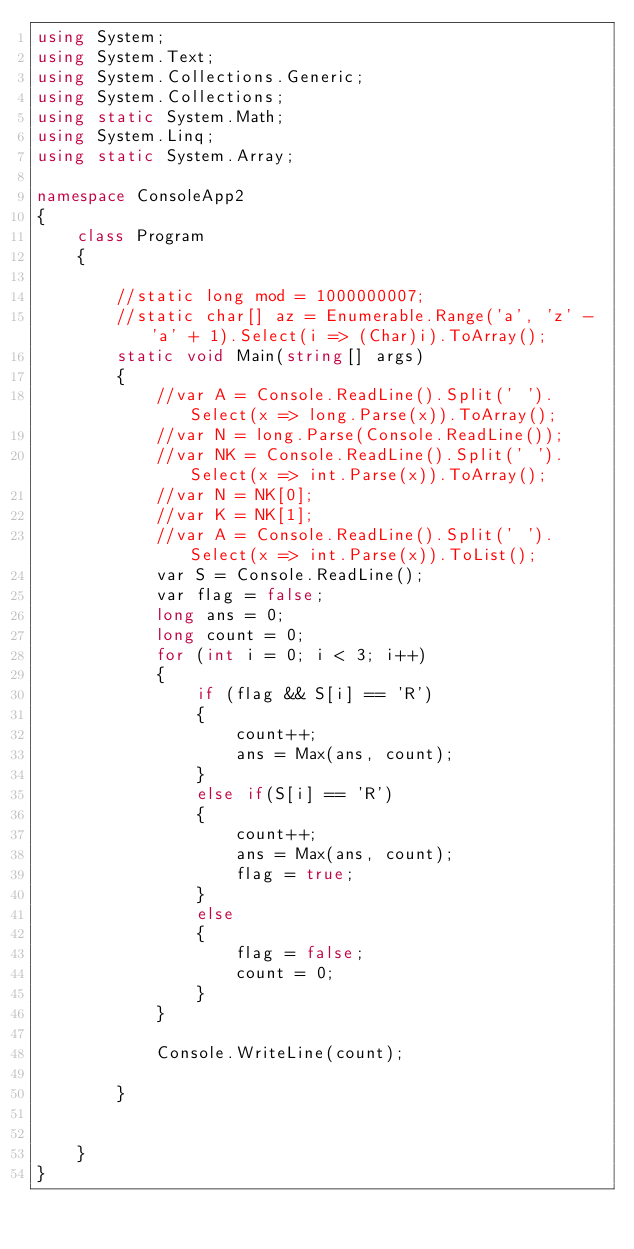Convert code to text. <code><loc_0><loc_0><loc_500><loc_500><_C#_>using System;
using System.Text;
using System.Collections.Generic;
using System.Collections;
using static System.Math;
using System.Linq;
using static System.Array;

namespace ConsoleApp2
{
    class Program
    {
        
        //static long mod = 1000000007;
        //static char[] az = Enumerable.Range('a', 'z' - 'a' + 1).Select(i => (Char)i).ToArray();
        static void Main(string[] args)
        {
            //var A = Console.ReadLine().Split(' ').Select(x => long.Parse(x)).ToArray();
            //var N = long.Parse(Console.ReadLine());
            //var NK = Console.ReadLine().Split(' ').Select(x => int.Parse(x)).ToArray();
            //var N = NK[0];
            //var K = NK[1];
            //var A = Console.ReadLine().Split(' ').Select(x => int.Parse(x)).ToList();
            var S = Console.ReadLine();
            var flag = false;
            long ans = 0;
            long count = 0;
            for (int i = 0; i < 3; i++)
            {
                if (flag && S[i] == 'R')
                {
                    count++;
                    ans = Max(ans, count);
                }
                else if(S[i] == 'R')
                {
                    count++;
                    ans = Max(ans, count);
                    flag = true;
                }
                else
                {
                    flag = false;
                    count = 0;
                }
            }
            
            Console.WriteLine(count);
           
        }


    }
}
</code> 